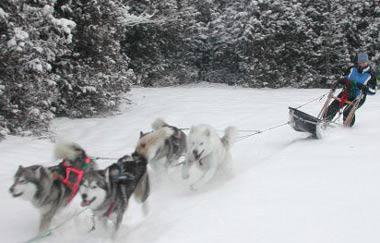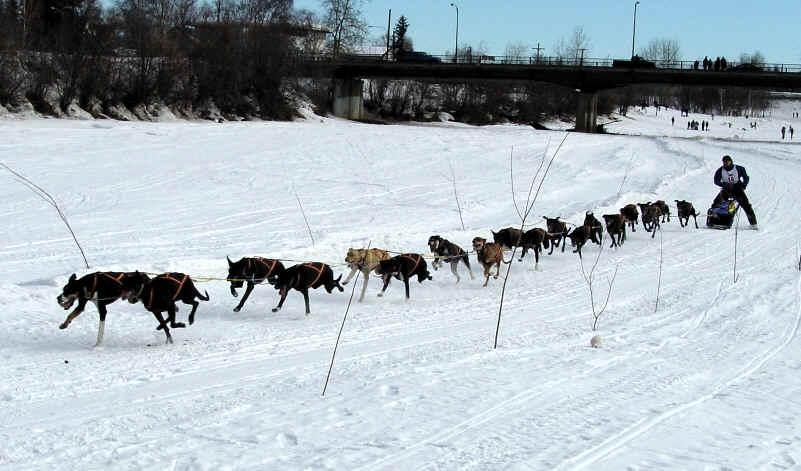The first image is the image on the left, the second image is the image on the right. For the images displayed, is the sentence "One image shows a sled dog team moving down a path in the snow, and the other image shows sled dogs that are not hitched or working." factually correct? Answer yes or no. No. The first image is the image on the left, the second image is the image on the right. Considering the images on both sides, is "Only one of the images shows a team of dogs pulling a sled." valid? Answer yes or no. No. 